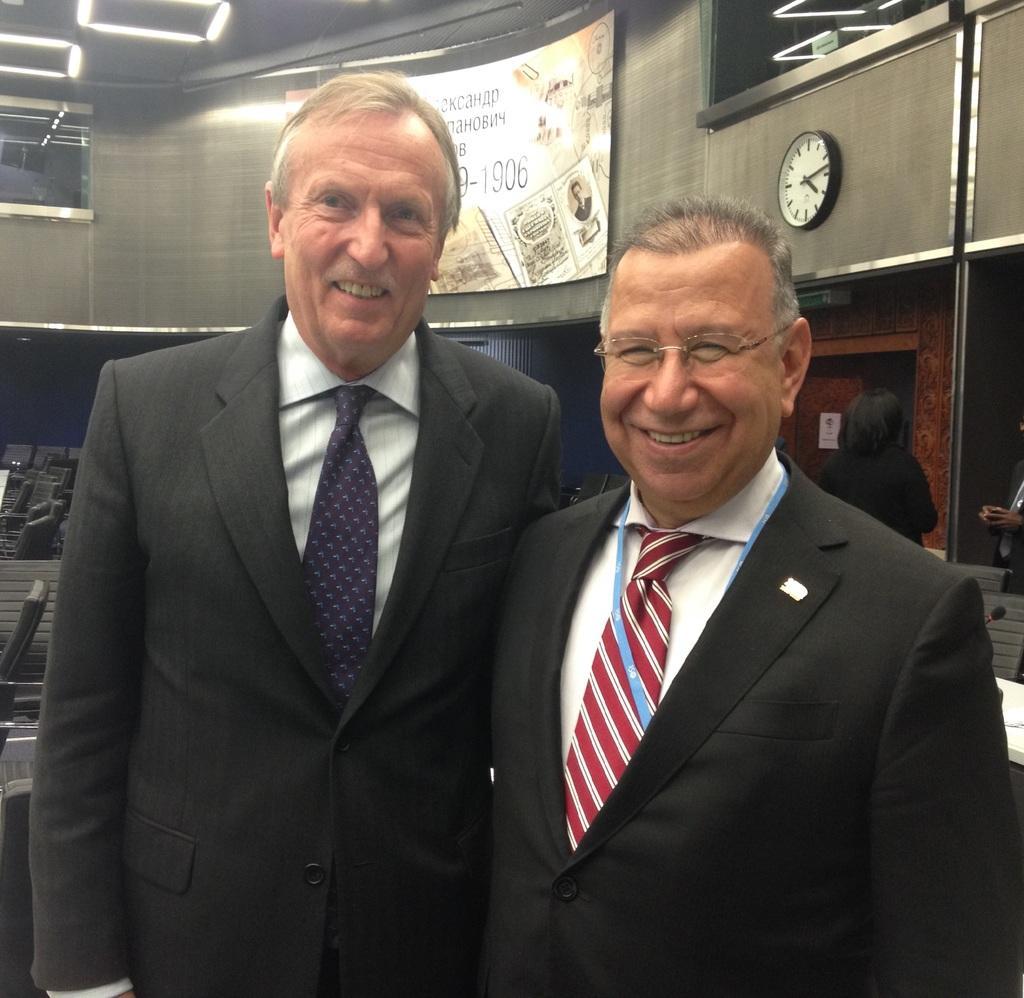In one or two sentences, can you explain what this image depicts? In this image there are two men standing. They are smiling. Behind them there are chairs. To the right there is a person behind them. At the top there is a wall. There are boards and a clock on the wall. In the top left there are lights to the ceiling. 